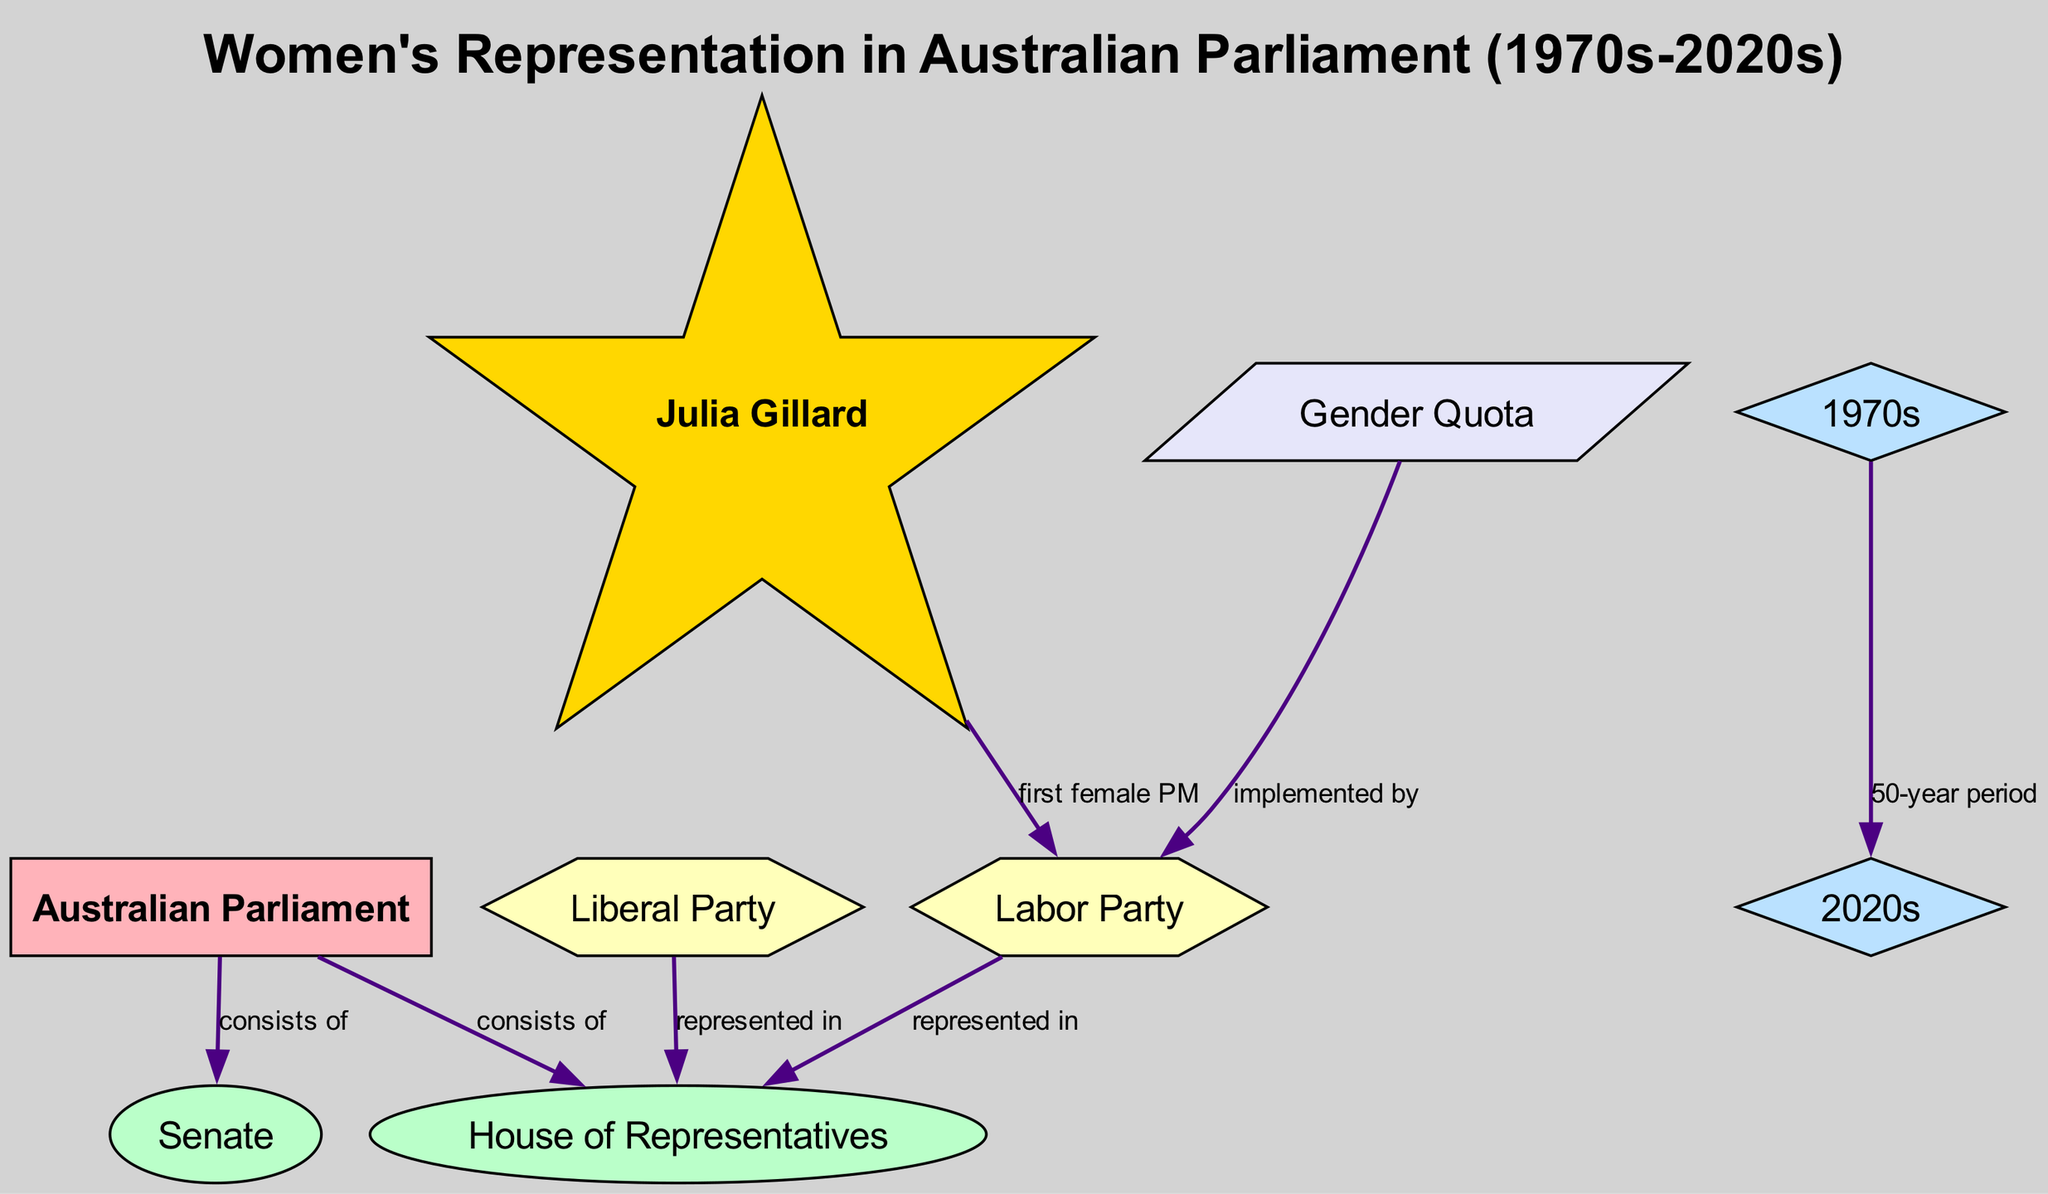What are the two chambers of the Australian Parliament? The diagram shows two nodes connected to the "Australian Parliament" node with the label "consists of." These nodes are "House of Representatives" and "Senate."
Answer: House of Representatives, Senate Which key figure is identified as the first female Prime Minister in the diagram? The diagram highlights the connection between "Julia Gillard" and "Labor Party" with the label "first female PM." Thus, Julia Gillard is the key figure identified.
Answer: Julia Gillard What time period does the diagram span for the analysis of women's representation? The diagram indicates that the analysis covers a 50-year period from "1970s" to "2020s," which is shown through the connecting edges labeled "50-year period."
Answer: 50-year period Which political party is associated with the implementation of a gender quota? The diagram includes a node for "Gender Quota" and connects it to the "Labor Party" with the label "implemented by," indicating Labour's association with the gender quota policy.
Answer: Labor Party How many nodes are present in the diagram? By counting the nodes listed in the diagram, there are a total of 9 nodes, each representing different entities related to women’s representation in the Australian Parliament.
Answer: 9 How many edges connect to the House of Representatives? The diagram shows that "House of Representatives" has two edges connected to it - one from the "Australian Parliament" (labelled "consists of") and another from both "Liberal Party" and "Labor Party" (labelled "represented in"). Therefore, there are two edges.
Answer: 2 What does the label "implemented by" specify in the diagram? The label "implemented by" specifies the relationship between the "Gender Quota" node and the "Labor Party" node. It indicates that the Labor Party is responsible for implementing the gender quota policy.
Answer: Labor Party What is the relationship between the time periods shown in the diagram? The diagram explicitly describes the relationship through an edge connecting "1970s" and "2020s" with the label "50-year period," which indicates the duration from the 1970s to the 2020s.
Answer: 50-year period Which party has representation in both chambers of the Australian Parliament as indicated in the diagram? The diagram shows edges from both the "Liberal Party" and "Labor Party" to the "House of Representatives," indicating their representation in that chamber. Hence, both parties are represented.
Answer: Both parties 